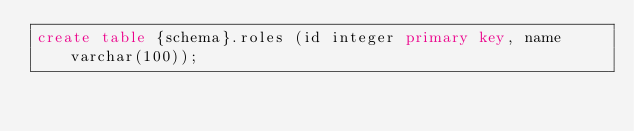Convert code to text. <code><loc_0><loc_0><loc_500><loc_500><_SQL_>create table {schema}.roles (id integer primary key, name varchar(100));
</code> 